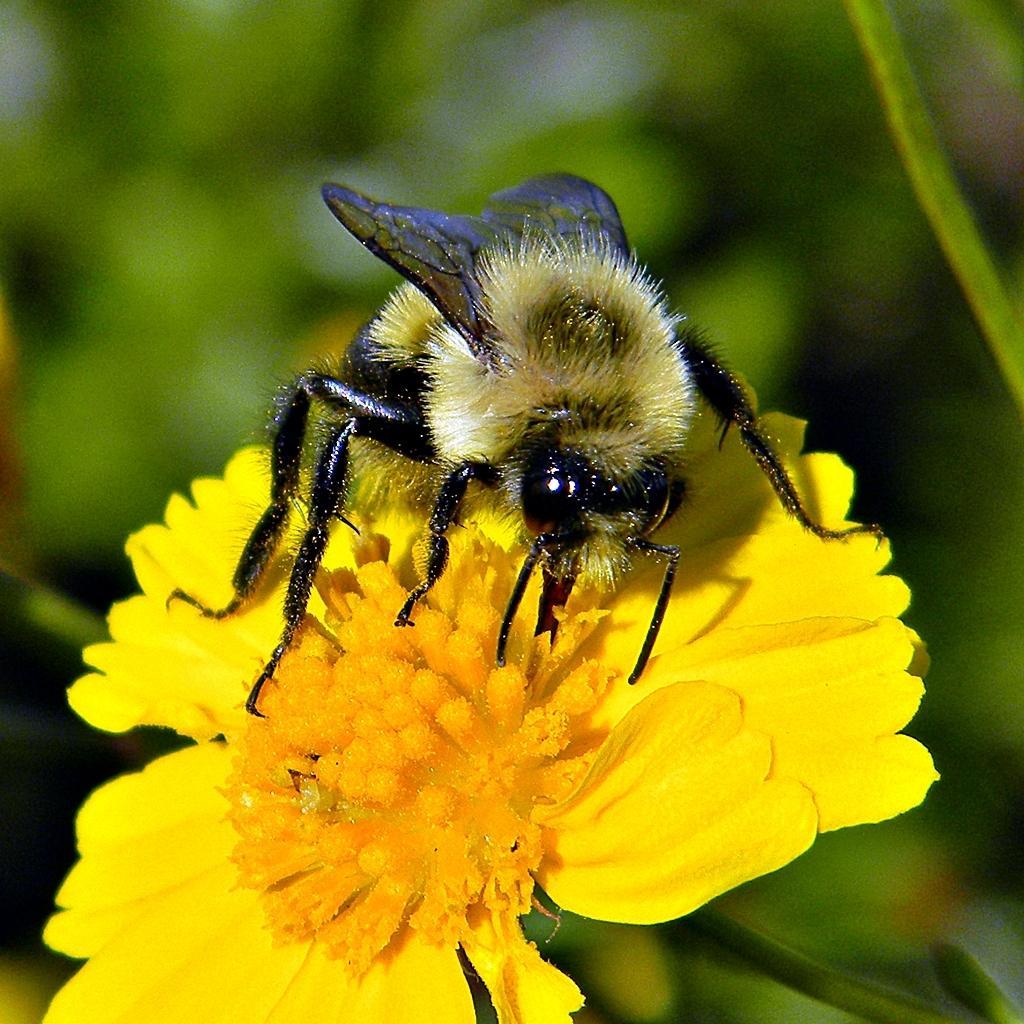Describe this image in one or two sentences. In this image I can see the insect on the yellow color flower. Background is in green color. 